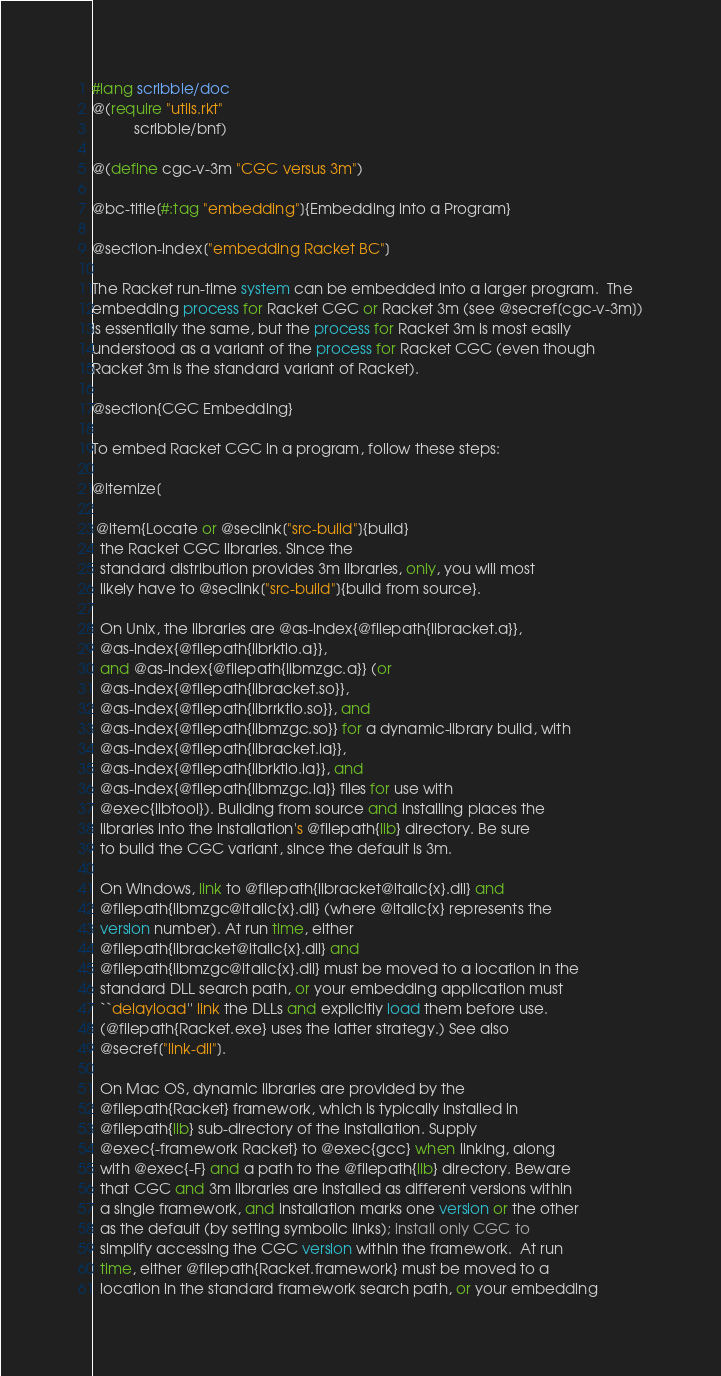Convert code to text. <code><loc_0><loc_0><loc_500><loc_500><_Racket_>#lang scribble/doc
@(require "utils.rkt"
          scribble/bnf)

@(define cgc-v-3m "CGC versus 3m")

@bc-title[#:tag "embedding"]{Embedding into a Program}

@section-index["embedding Racket BC"]

The Racket run-time system can be embedded into a larger program.  The
embedding process for Racket CGC or Racket 3m (see @secref[cgc-v-3m])
is essentially the same, but the process for Racket 3m is most easily
understood as a variant of the process for Racket CGC (even though
Racket 3m is the standard variant of Racket).

@section{CGC Embedding}

To embed Racket CGC in a program, follow these steps:

@itemize[

 @item{Locate or @seclink["src-build"]{build}
  the Racket CGC libraries. Since the
  standard distribution provides 3m libraries, only, you will most
  likely have to @seclink["src-build"]{build from source}.

  On Unix, the libraries are @as-index{@filepath{libracket.a}},
  @as-index{@filepath{librktio.a}},
  and @as-index{@filepath{libmzgc.a}} (or
  @as-index{@filepath{libracket.so}},
  @as-index{@filepath{librrktio.so}}, and
  @as-index{@filepath{libmzgc.so}} for a dynamic-library build, with
  @as-index{@filepath{libracket.la}},
  @as-index{@filepath{librktio.la}}, and
  @as-index{@filepath{libmzgc.la}} files for use with
  @exec{libtool}). Building from source and installing places the
  libraries into the installation's @filepath{lib} directory. Be sure
  to build the CGC variant, since the default is 3m.

  On Windows, link to @filepath{libracket@italic{x}.dll} and
  @filepath{libmzgc@italic{x}.dll} (where @italic{x} represents the
  version number). At run time, either
  @filepath{libracket@italic{x}.dll} and
  @filepath{libmzgc@italic{x}.dll} must be moved to a location in the
  standard DLL search path, or your embedding application must
  ``delayload'' link the DLLs and explicitly load them before use.
  (@filepath{Racket.exe} uses the latter strategy.) See also
  @secref["link-dll"].

  On Mac OS, dynamic libraries are provided by the
  @filepath{Racket} framework, which is typically installed in
  @filepath{lib} sub-directory of the installation. Supply
  @exec{-framework Racket} to @exec{gcc} when linking, along
  with @exec{-F} and a path to the @filepath{lib} directory. Beware
  that CGC and 3m libraries are installed as different versions within
  a single framework, and installation marks one version or the other
  as the default (by setting symbolic links); install only CGC to
  simplify accessing the CGC version within the framework.  At run
  time, either @filepath{Racket.framework} must be moved to a
  location in the standard framework search path, or your embedding</code> 